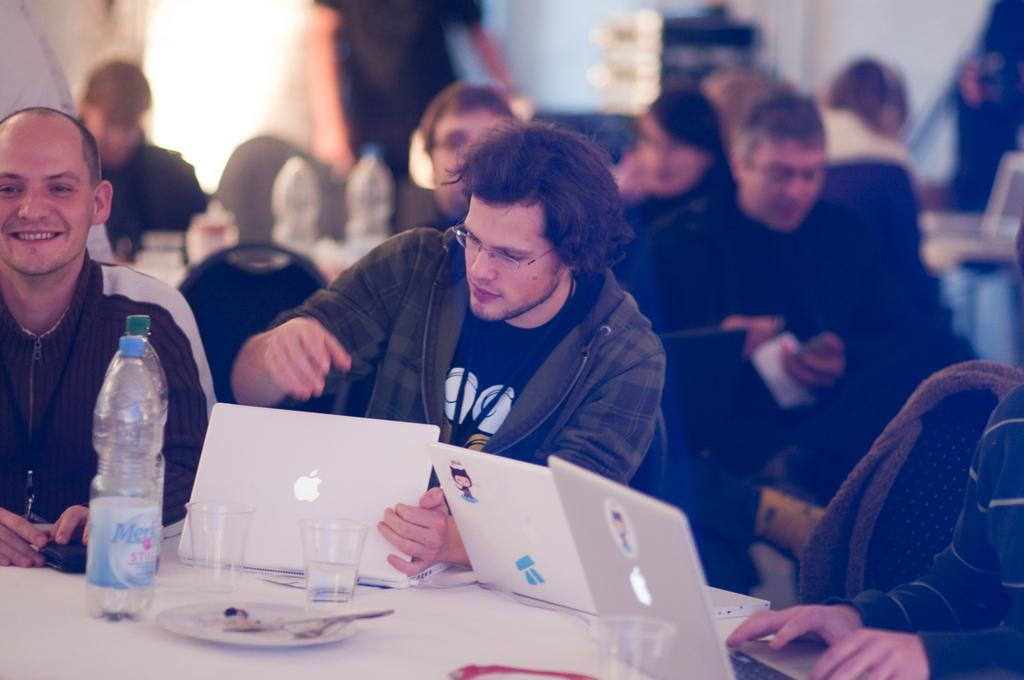What are the people in the image doing? There are people sitting on chairs and standing in the image. What objects can be seen on the table in the image? There are bottles, glasses, laptops, plates, and spoons on the table in the image. What is visible in the background of the image? There is a wall visible in the background of the image. How many bikes are parked next to the people in the image? There are no bikes visible in the image. What type of quiver is being used by the person standing in the image? There is no quiver present in the image. 